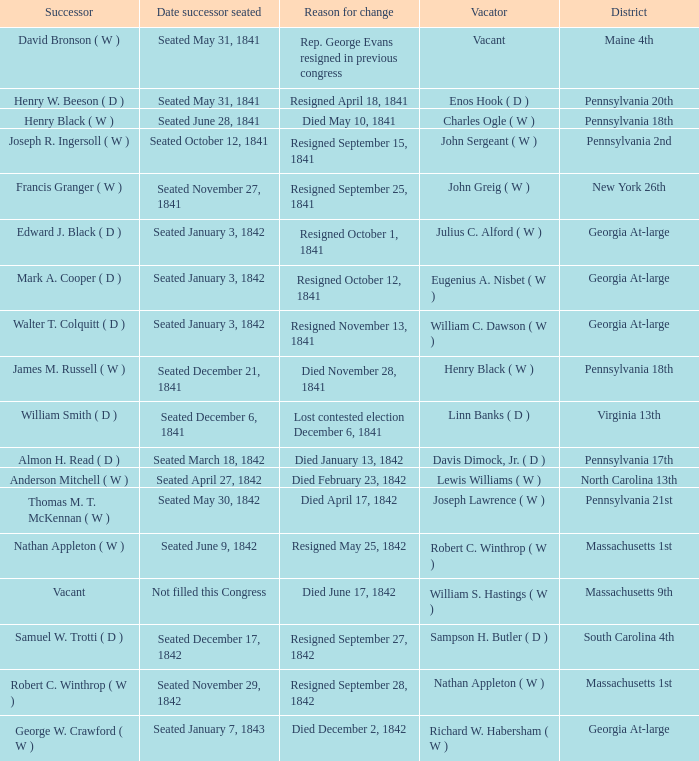Name the date successor seated for pennsylvania 17th Seated March 18, 1842. 